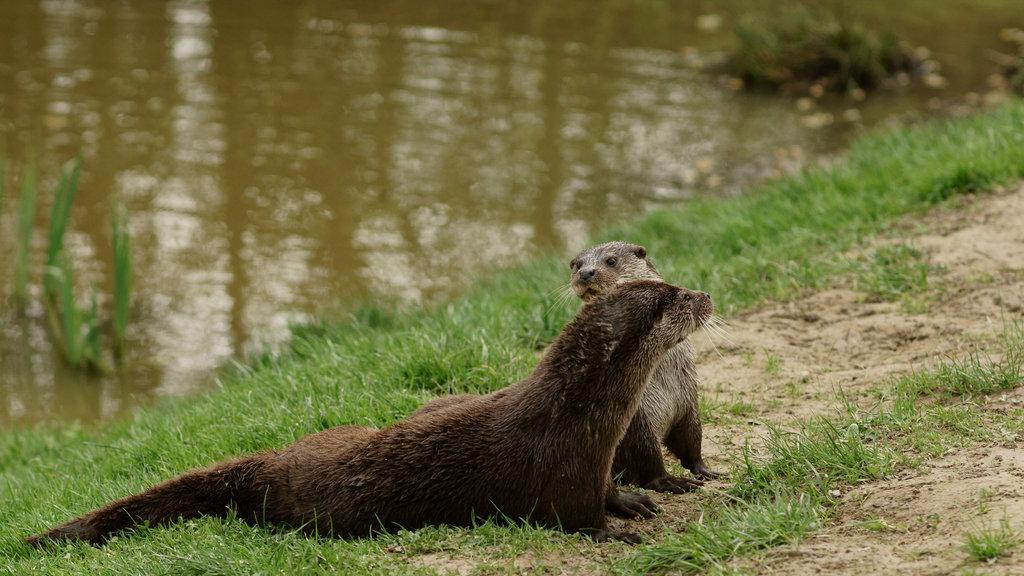Can you describe this image briefly? In this picture we can see animals on the ground, here we can see grass and we can see water in the background. 